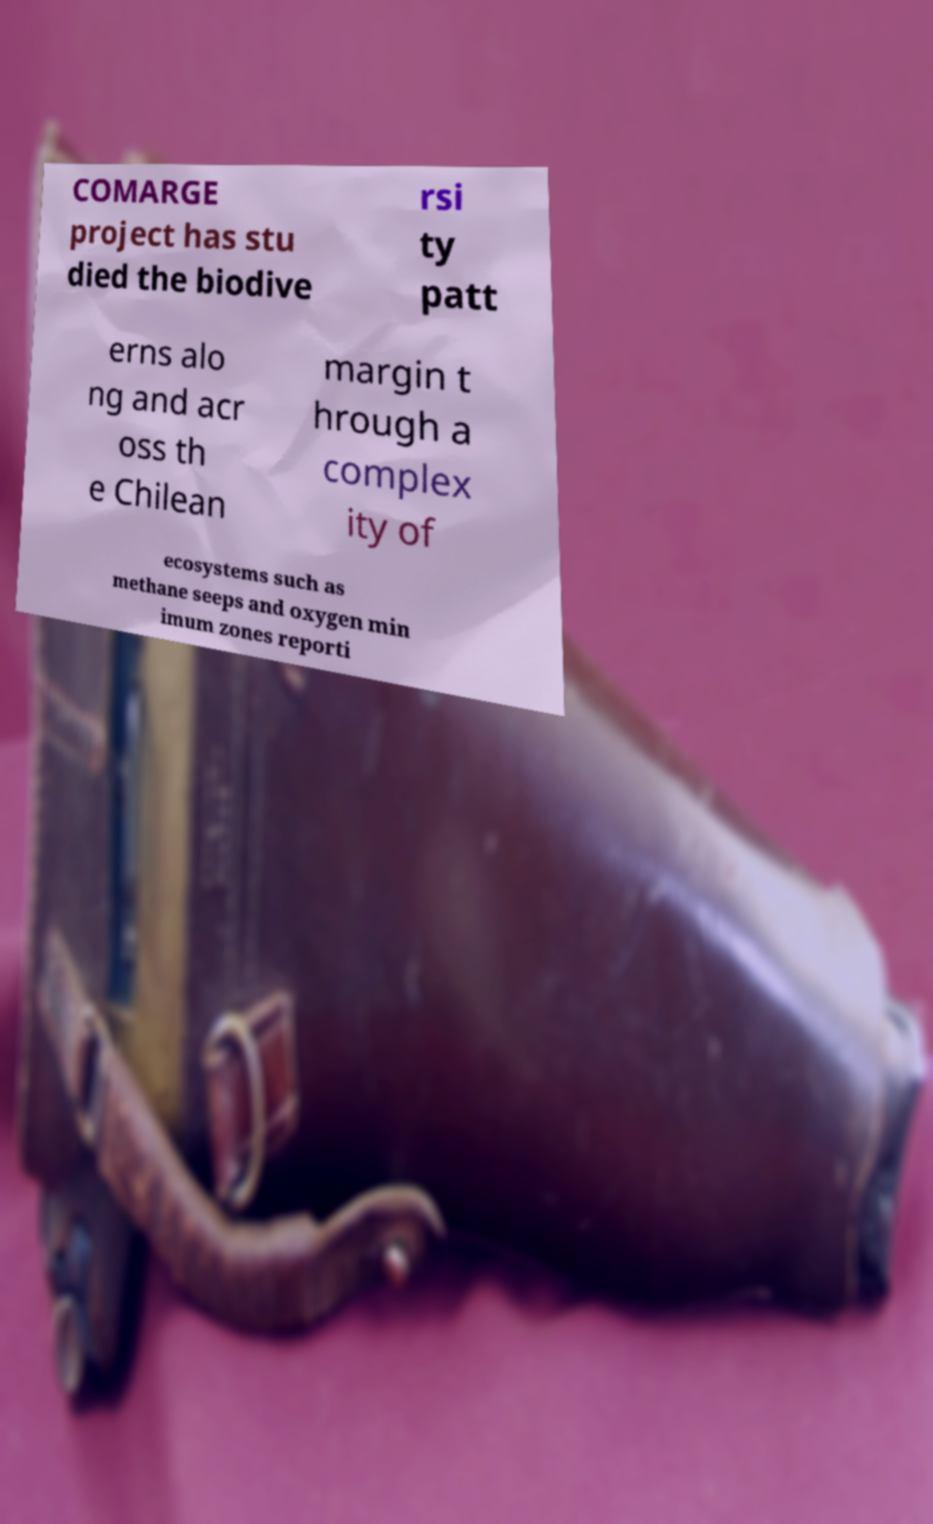Can you accurately transcribe the text from the provided image for me? COMARGE project has stu died the biodive rsi ty patt erns alo ng and acr oss th e Chilean margin t hrough a complex ity of ecosystems such as methane seeps and oxygen min imum zones reporti 